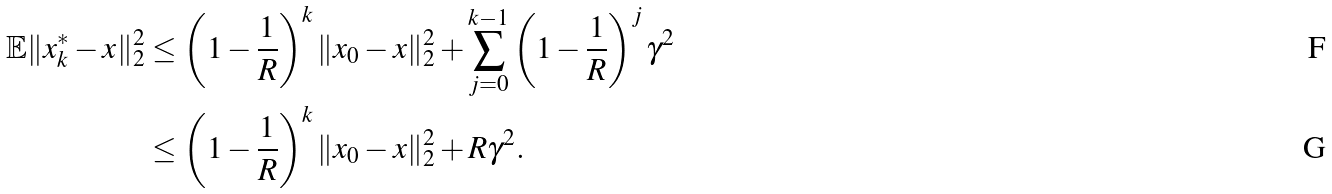<formula> <loc_0><loc_0><loc_500><loc_500>\mathbb { E } \| x _ { k } ^ { * } - x \| _ { 2 } ^ { 2 } & \leq \left ( 1 - \frac { 1 } { R } \right ) ^ { k } \| x _ { 0 } - x \| _ { 2 } ^ { 2 } + \sum _ { j = 0 } ^ { k - 1 } \left ( 1 - \frac { 1 } { R } \right ) ^ { j } \gamma ^ { 2 } \\ & \leq \left ( 1 - \frac { 1 } { R } \right ) ^ { k } \| x _ { 0 } - x \| _ { 2 } ^ { 2 } + R \gamma ^ { 2 } .</formula> 